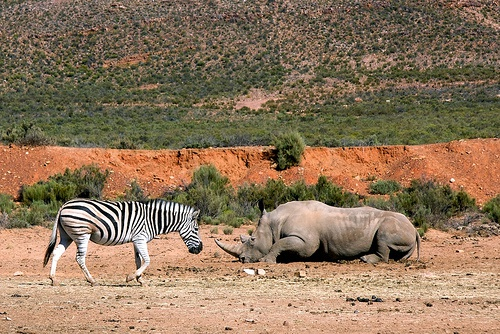Describe the objects in this image and their specific colors. I can see a zebra in darkgreen, white, black, gray, and darkgray tones in this image. 